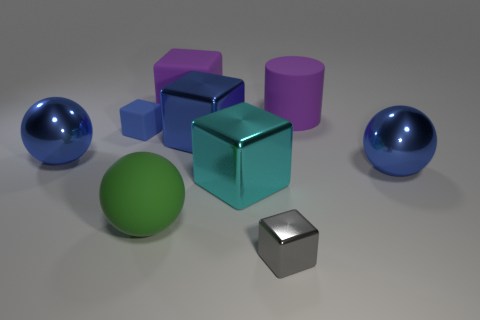Subtract all big purple cubes. How many cubes are left? 4 Subtract all gray cubes. How many blue balls are left? 2 Subtract all blue cubes. How many cubes are left? 3 Subtract 4 cubes. How many cubes are left? 1 Subtract all spheres. How many objects are left? 6 Subtract 0 red blocks. How many objects are left? 9 Subtract all gray cubes. Subtract all gray cylinders. How many cubes are left? 4 Subtract all small blue things. Subtract all big cyan metallic things. How many objects are left? 7 Add 1 tiny gray metallic blocks. How many tiny gray metallic blocks are left? 2 Add 8 green metallic spheres. How many green metallic spheres exist? 8 